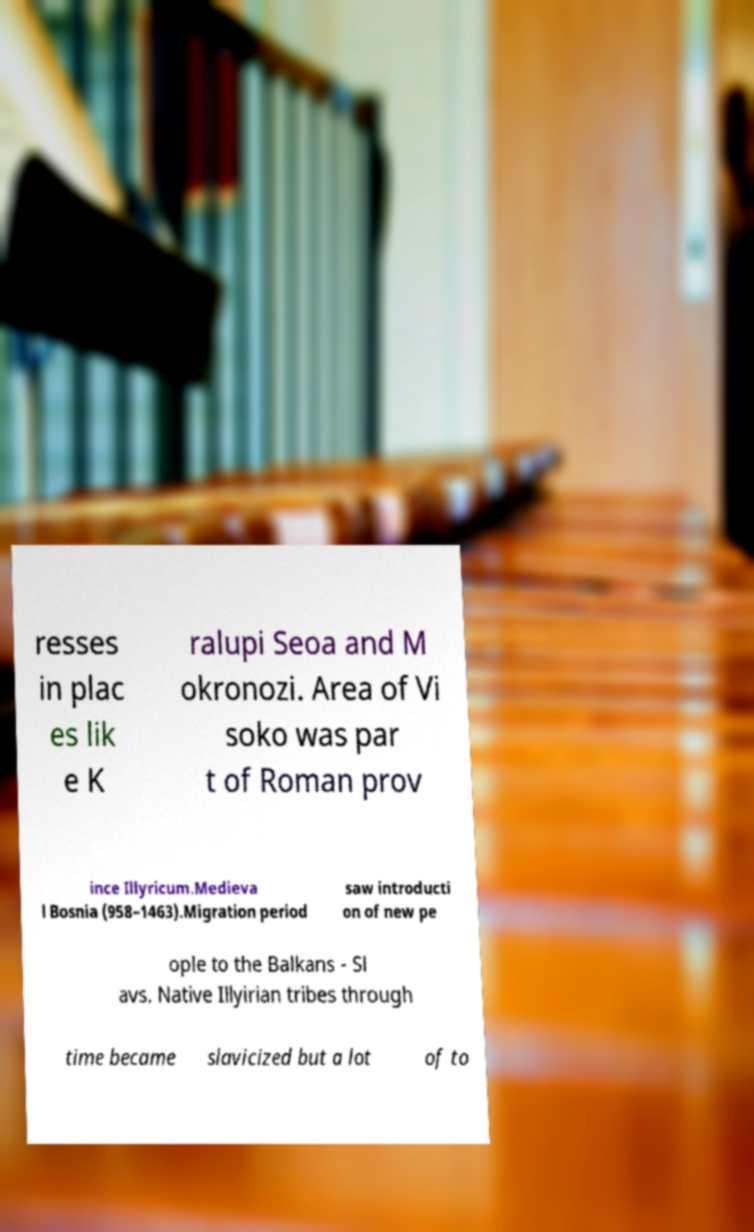Can you read and provide the text displayed in the image?This photo seems to have some interesting text. Can you extract and type it out for me? resses in plac es lik e K ralupi Seoa and M okronozi. Area of Vi soko was par t of Roman prov ince Illyricum.Medieva l Bosnia (958–1463).Migration period saw introducti on of new pe ople to the Balkans - Sl avs. Native Illyirian tribes through time became slavicized but a lot of to 